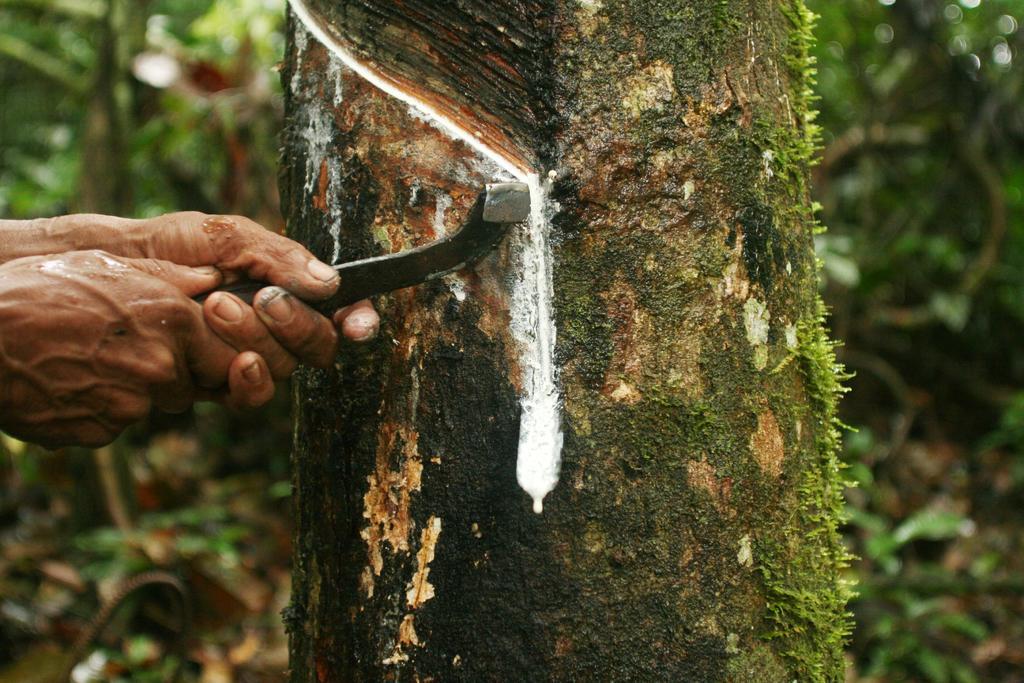Could you give a brief overview of what you see in this image? In this picture we can see stem of the tree and we can see person hands holding an object. 